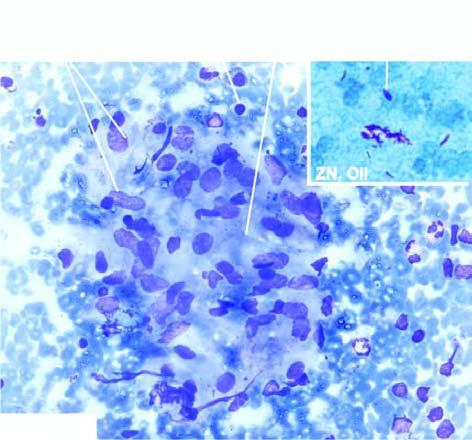does the surrounding zone show ziehl-neelsen staining having many tubercle bacilli?
Answer the question using a single word or phrase. No 